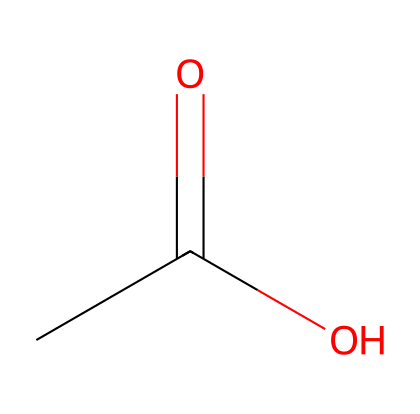What is the name of this chemical? The SMILES representation CC(=O)O corresponds to acetic acid, which is a two-carbon carboxylic acid.
Answer: acetic acid How many carbon atoms are in acetic acid? In the structure, the first part "CC" indicates there are two carbon atoms present in this molecule.
Answer: 2 How many total hydrogen atoms are present? The structure CC(=O)O shows two hydrogen atoms on the first carbon, one on the second carbon, and one from the hydroxyl (–OH) group, totaling four hydrogen atoms.
Answer: 4 What type of acid is acetic acid? Acetic acid is classified as a carboxylic acid due to the presence of the carboxyl group (–COOH) in its structure.
Answer: carboxylic acid What functional group is present in this acid? The acid has a carboxyl group (–COOH), which is identified by its structure consisting of a carbon atom double-bonded to oxygen and single-bonded to a hydroxyl group.
Answer: carboxyl group Is acetic acid a strong or weak acid? Acetic acid is a weak acid because it does not dissociate fully in solution, meaning it only partially donates protons (H+) when dissolved in water.
Answer: weak acid What is the pH range of acetic acid in solution? The pH of acetic acid solutions typically ranges from 2.4 to 3.4, indicating its acidic nature.
Answer: 2.4 - 3.4 